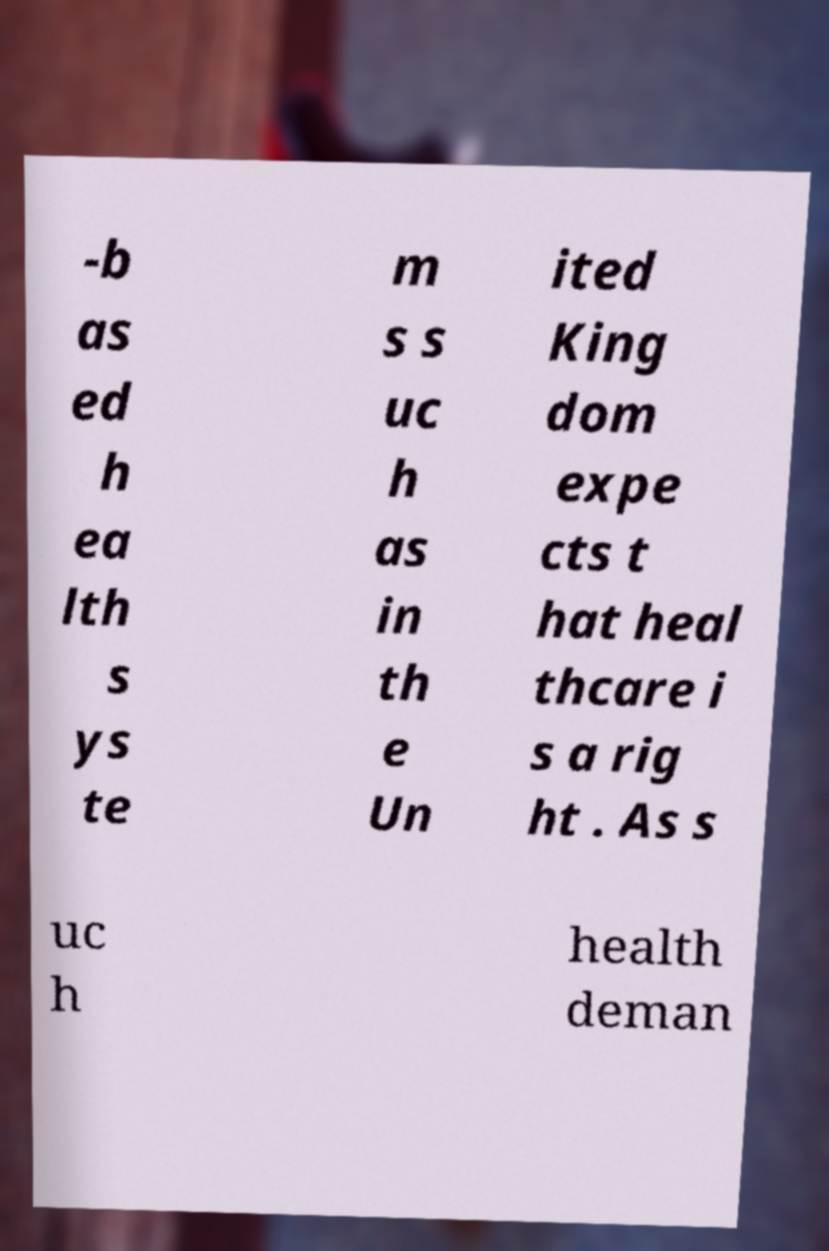What messages or text are displayed in this image? I need them in a readable, typed format. -b as ed h ea lth s ys te m s s uc h as in th e Un ited King dom expe cts t hat heal thcare i s a rig ht . As s uc h health deman 